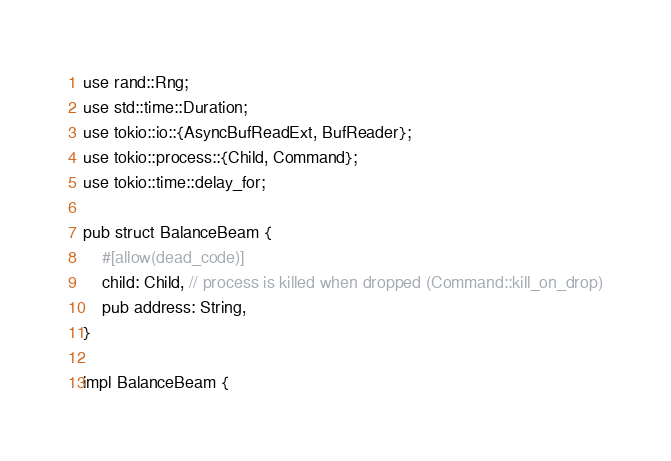Convert code to text. <code><loc_0><loc_0><loc_500><loc_500><_Rust_>use rand::Rng;
use std::time::Duration;
use tokio::io::{AsyncBufReadExt, BufReader};
use tokio::process::{Child, Command};
use tokio::time::delay_for;

pub struct BalanceBeam {
    #[allow(dead_code)]
    child: Child, // process is killed when dropped (Command::kill_on_drop)
    pub address: String,
}

impl BalanceBeam {</code> 